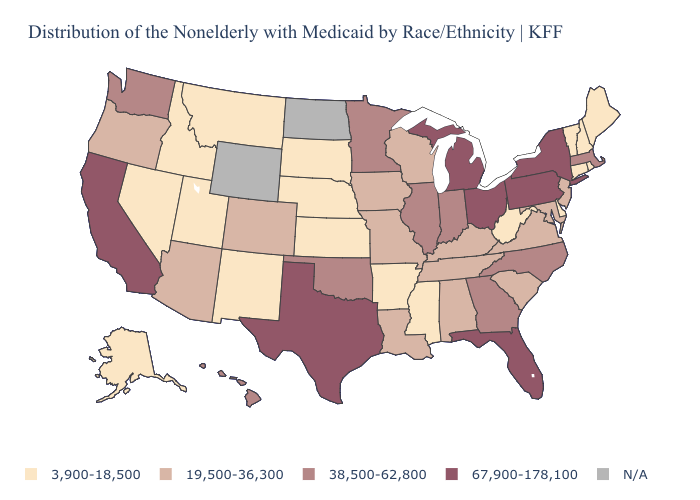Does the first symbol in the legend represent the smallest category?
Quick response, please. Yes. What is the value of Delaware?
Write a very short answer. 3,900-18,500. Among the states that border Illinois , which have the lowest value?
Answer briefly. Iowa, Kentucky, Missouri, Wisconsin. What is the value of Ohio?
Short answer required. 67,900-178,100. What is the value of Florida?
Quick response, please. 67,900-178,100. Name the states that have a value in the range 67,900-178,100?
Keep it brief. California, Florida, Michigan, New York, Ohio, Pennsylvania, Texas. What is the value of Georgia?
Keep it brief. 38,500-62,800. What is the value of Connecticut?
Be succinct. 3,900-18,500. Which states have the lowest value in the USA?
Concise answer only. Alaska, Arkansas, Connecticut, Delaware, Idaho, Kansas, Maine, Mississippi, Montana, Nebraska, Nevada, New Hampshire, New Mexico, Rhode Island, South Dakota, Utah, Vermont, West Virginia. What is the lowest value in the USA?
Keep it brief. 3,900-18,500. What is the value of Iowa?
Be succinct. 19,500-36,300. What is the highest value in the West ?
Concise answer only. 67,900-178,100. What is the value of Arkansas?
Write a very short answer. 3,900-18,500. What is the value of New York?
Answer briefly. 67,900-178,100. Among the states that border Delaware , which have the lowest value?
Give a very brief answer. Maryland, New Jersey. 